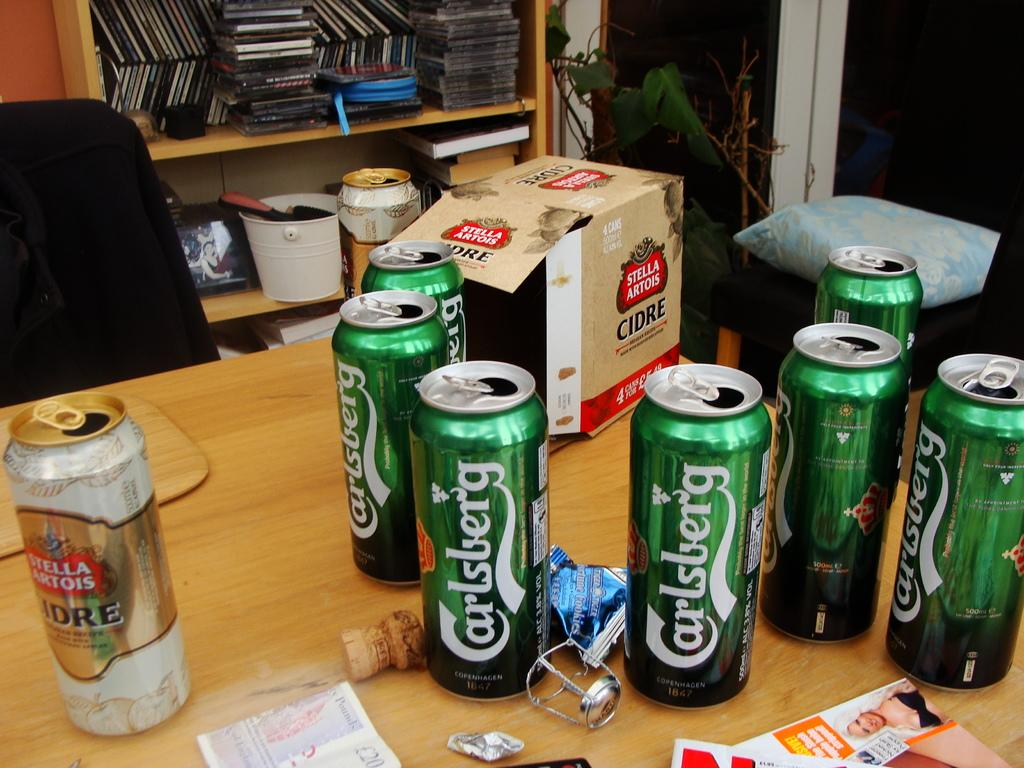<image>
Present a compact description of the photo's key features. Seven open cans of Carlsberg beer are on a wooden table with one open can of Stella Artois. 